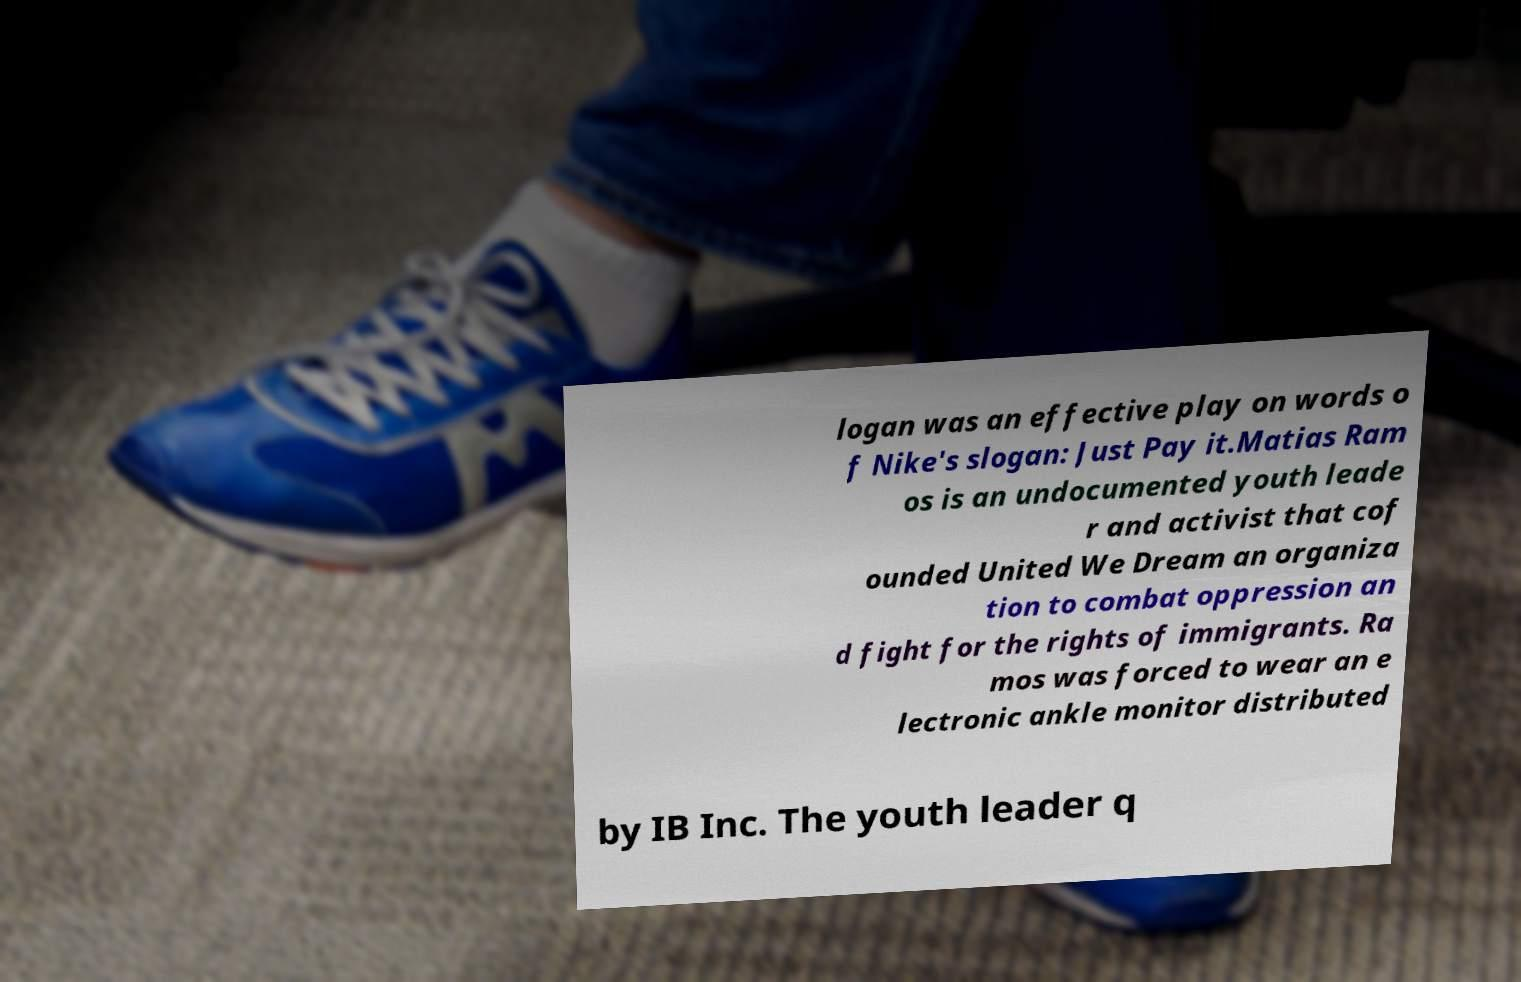For documentation purposes, I need the text within this image transcribed. Could you provide that? logan was an effective play on words o f Nike's slogan: Just Pay it.Matias Ram os is an undocumented youth leade r and activist that cof ounded United We Dream an organiza tion to combat oppression an d fight for the rights of immigrants. Ra mos was forced to wear an e lectronic ankle monitor distributed by IB Inc. The youth leader q 